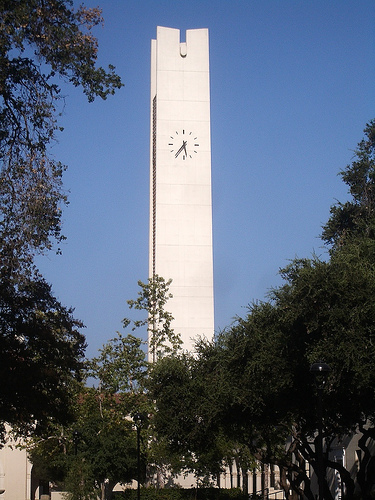<image>What monument is this? It is unknown what monument this is. It could be the Washington monument, clock tower, Big Ben, National monument, Acme clock tower, or Smith tower. What monument is this? I am not sure which monument it is. It can be the Washington Monument, Clock Tower, Big Ben, or National Monument. 